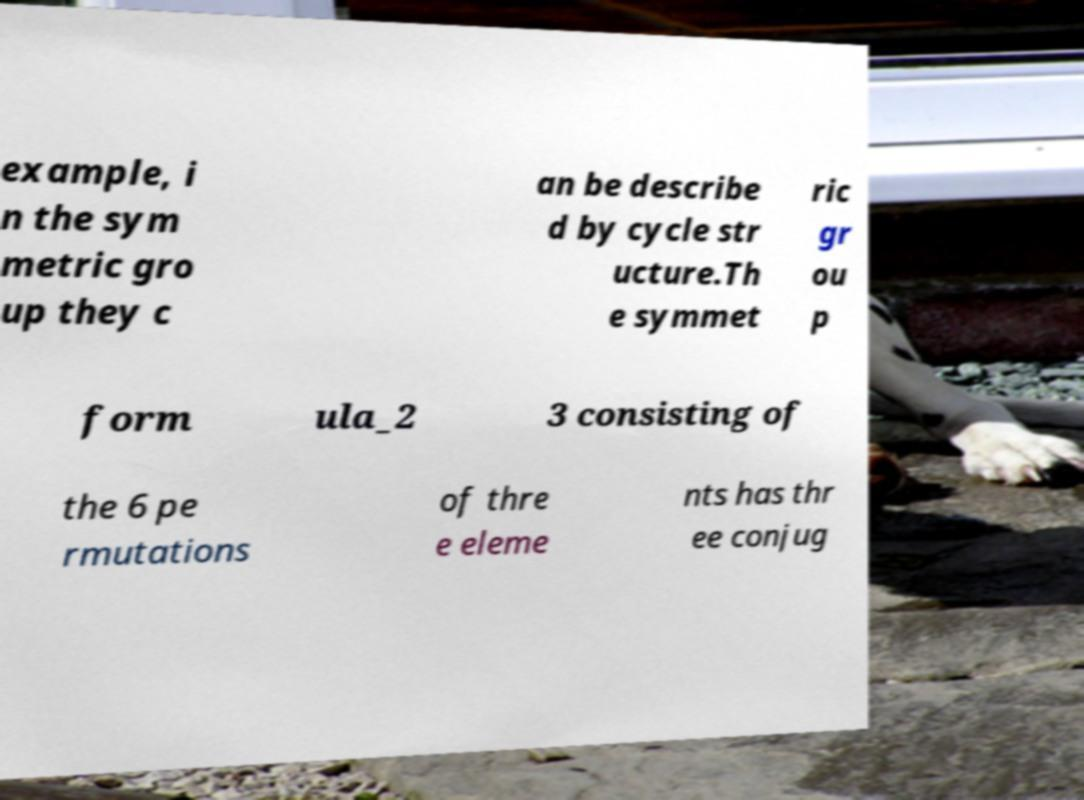Could you extract and type out the text from this image? example, i n the sym metric gro up they c an be describe d by cycle str ucture.Th e symmet ric gr ou p form ula_2 3 consisting of the 6 pe rmutations of thre e eleme nts has thr ee conjug 